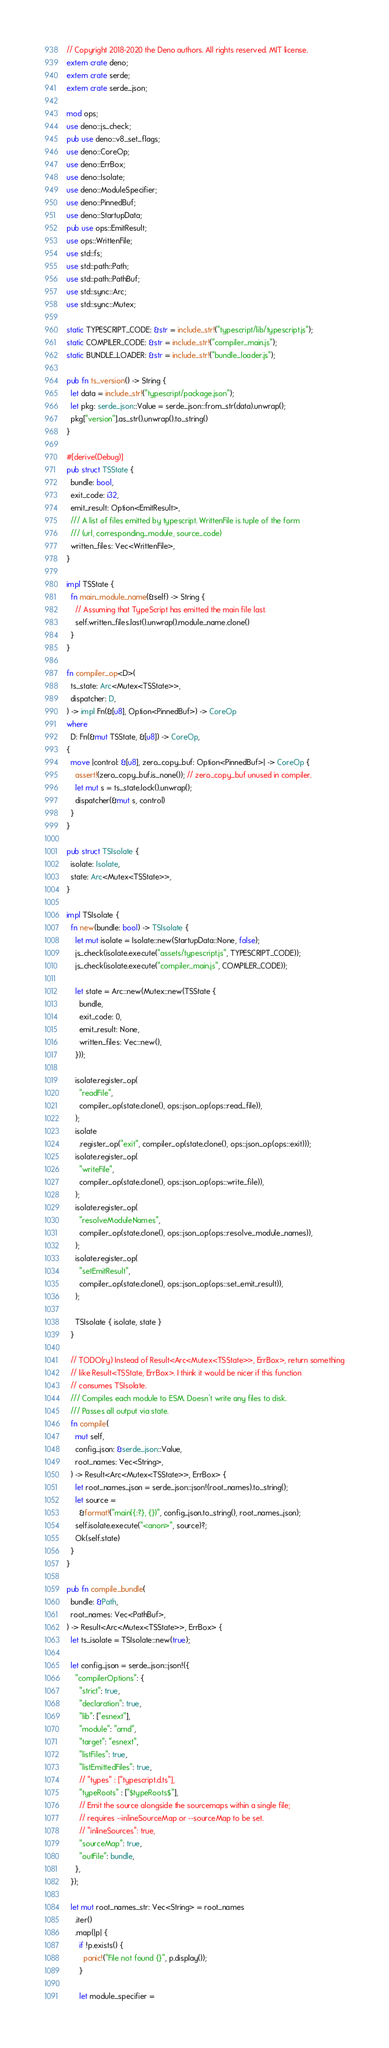<code> <loc_0><loc_0><loc_500><loc_500><_Rust_>// Copyright 2018-2020 the Deno authors. All rights reserved. MIT license.
extern crate deno;
extern crate serde;
extern crate serde_json;

mod ops;
use deno::js_check;
pub use deno::v8_set_flags;
use deno::CoreOp;
use deno::ErrBox;
use deno::Isolate;
use deno::ModuleSpecifier;
use deno::PinnedBuf;
use deno::StartupData;
pub use ops::EmitResult;
use ops::WrittenFile;
use std::fs;
use std::path::Path;
use std::path::PathBuf;
use std::sync::Arc;
use std::sync::Mutex;

static TYPESCRIPT_CODE: &str = include_str!("typescript/lib/typescript.js");
static COMPILER_CODE: &str = include_str!("compiler_main.js");
static BUNDLE_LOADER: &str = include_str!("bundle_loader.js");

pub fn ts_version() -> String {
  let data = include_str!("typescript/package.json");
  let pkg: serde_json::Value = serde_json::from_str(data).unwrap();
  pkg["version"].as_str().unwrap().to_string()
}

#[derive(Debug)]
pub struct TSState {
  bundle: bool,
  exit_code: i32,
  emit_result: Option<EmitResult>,
  /// A list of files emitted by typescript. WrittenFile is tuple of the form
  /// (url, corresponding_module, source_code)
  written_files: Vec<WrittenFile>,
}

impl TSState {
  fn main_module_name(&self) -> String {
    // Assuming that TypeScript has emitted the main file last.
    self.written_files.last().unwrap().module_name.clone()
  }
}

fn compiler_op<D>(
  ts_state: Arc<Mutex<TSState>>,
  dispatcher: D,
) -> impl Fn(&[u8], Option<PinnedBuf>) -> CoreOp
where
  D: Fn(&mut TSState, &[u8]) -> CoreOp,
{
  move |control: &[u8], zero_copy_buf: Option<PinnedBuf>| -> CoreOp {
    assert!(zero_copy_buf.is_none()); // zero_copy_buf unused in compiler.
    let mut s = ts_state.lock().unwrap();
    dispatcher(&mut s, control)
  }
}

pub struct TSIsolate {
  isolate: Isolate,
  state: Arc<Mutex<TSState>>,
}

impl TSIsolate {
  fn new(bundle: bool) -> TSIsolate {
    let mut isolate = Isolate::new(StartupData::None, false);
    js_check(isolate.execute("assets/typescript.js", TYPESCRIPT_CODE));
    js_check(isolate.execute("compiler_main.js", COMPILER_CODE));

    let state = Arc::new(Mutex::new(TSState {
      bundle,
      exit_code: 0,
      emit_result: None,
      written_files: Vec::new(),
    }));

    isolate.register_op(
      "readFile",
      compiler_op(state.clone(), ops::json_op(ops::read_file)),
    );
    isolate
      .register_op("exit", compiler_op(state.clone(), ops::json_op(ops::exit)));
    isolate.register_op(
      "writeFile",
      compiler_op(state.clone(), ops::json_op(ops::write_file)),
    );
    isolate.register_op(
      "resolveModuleNames",
      compiler_op(state.clone(), ops::json_op(ops::resolve_module_names)),
    );
    isolate.register_op(
      "setEmitResult",
      compiler_op(state.clone(), ops::json_op(ops::set_emit_result)),
    );

    TSIsolate { isolate, state }
  }

  // TODO(ry) Instead of Result<Arc<Mutex<TSState>>, ErrBox>, return something
  // like Result<TSState, ErrBox>. I think it would be nicer if this function
  // consumes TSIsolate.
  /// Compiles each module to ESM. Doesn't write any files to disk.
  /// Passes all output via state.
  fn compile(
    mut self,
    config_json: &serde_json::Value,
    root_names: Vec<String>,
  ) -> Result<Arc<Mutex<TSState>>, ErrBox> {
    let root_names_json = serde_json::json!(root_names).to_string();
    let source =
      &format!("main({:?}, {})", config_json.to_string(), root_names_json);
    self.isolate.execute("<anon>", source)?;
    Ok(self.state)
  }
}

pub fn compile_bundle(
  bundle: &Path,
  root_names: Vec<PathBuf>,
) -> Result<Arc<Mutex<TSState>>, ErrBox> {
  let ts_isolate = TSIsolate::new(true);

  let config_json = serde_json::json!({
    "compilerOptions": {
      "strict": true,
      "declaration": true,
      "lib": ["esnext"],
      "module": "amd",
      "target": "esnext",
      "listFiles": true,
      "listEmittedFiles": true,
      // "types" : ["typescript.d.ts"],
      "typeRoots" : ["$typeRoots$"],
      // Emit the source alongside the sourcemaps within a single file;
      // requires --inlineSourceMap or --sourceMap to be set.
      // "inlineSources": true,
      "sourceMap": true,
      "outFile": bundle,
    },
  });

  let mut root_names_str: Vec<String> = root_names
    .iter()
    .map(|p| {
      if !p.exists() {
        panic!("File not found {}", p.display());
      }

      let module_specifier =</code> 